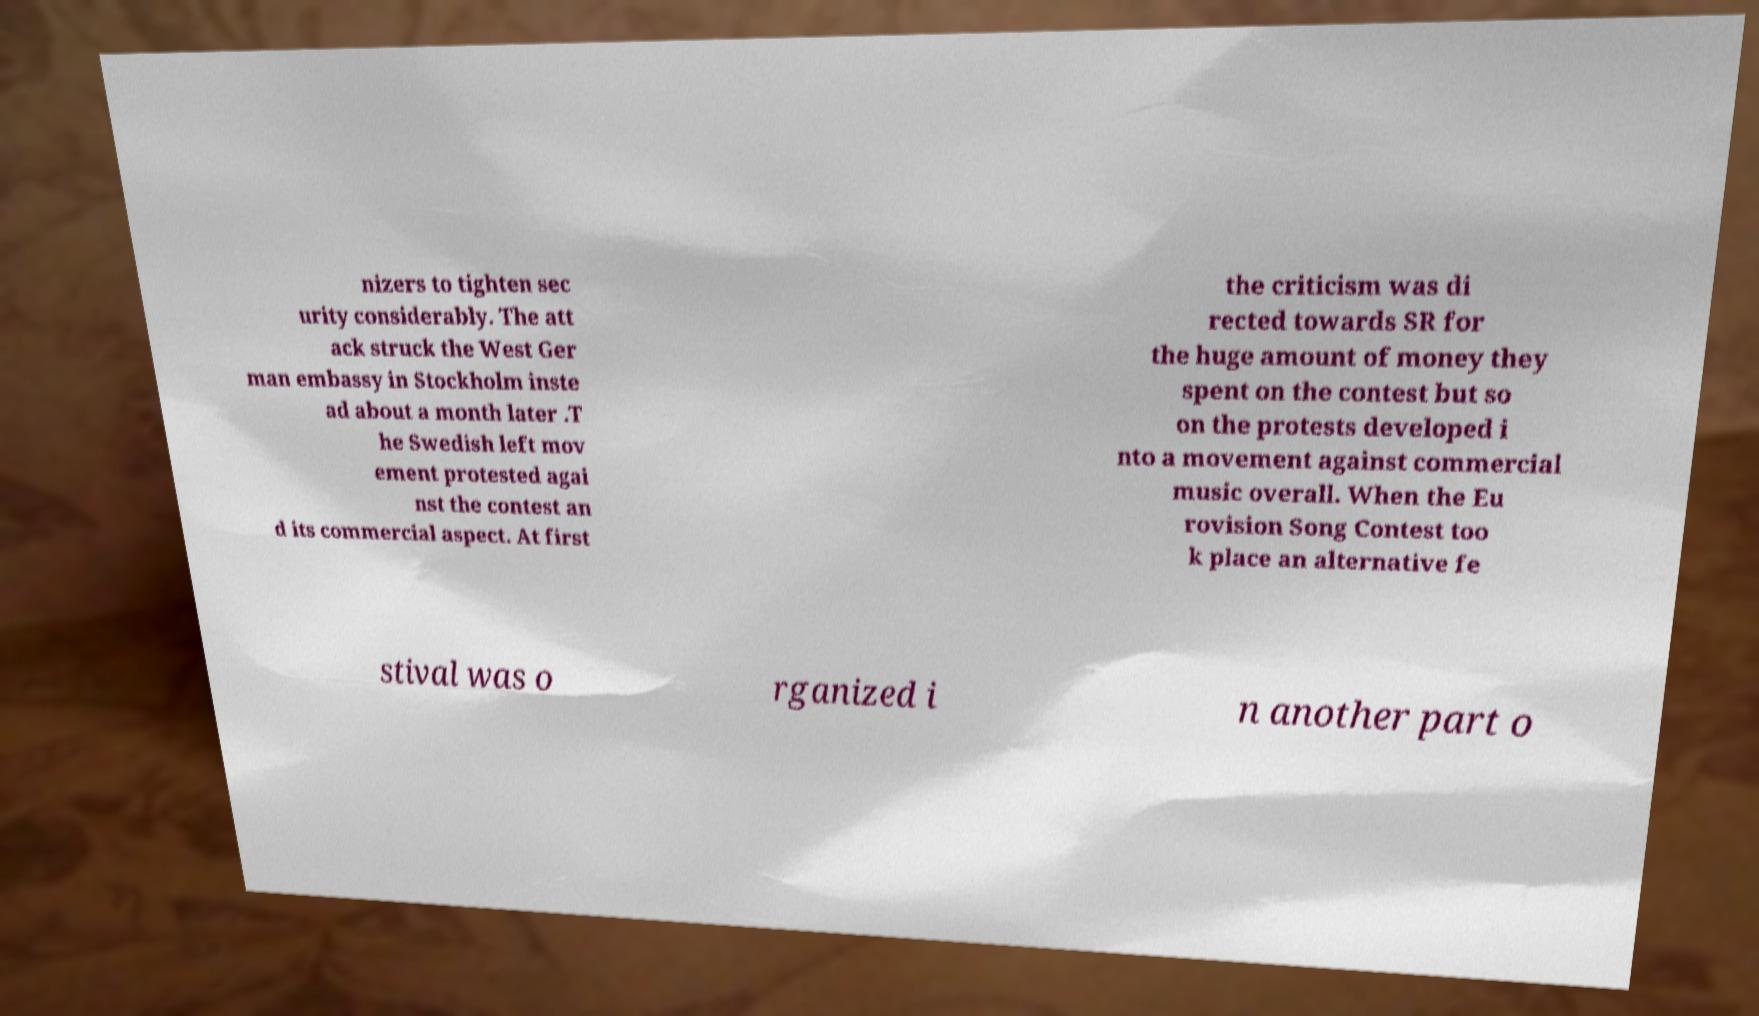For documentation purposes, I need the text within this image transcribed. Could you provide that? nizers to tighten sec urity considerably. The att ack struck the West Ger man embassy in Stockholm inste ad about a month later .T he Swedish left mov ement protested agai nst the contest an d its commercial aspect. At first the criticism was di rected towards SR for the huge amount of money they spent on the contest but so on the protests developed i nto a movement against commercial music overall. When the Eu rovision Song Contest too k place an alternative fe stival was o rganized i n another part o 